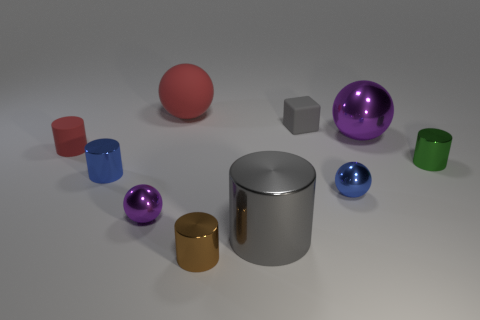How big is the blue metal ball?
Provide a succinct answer. Small. There is a tiny brown metallic thing; what shape is it?
Your answer should be compact. Cylinder. There is a big red thing; is it the same shape as the gray rubber thing behind the green shiny thing?
Provide a succinct answer. No. There is a small thing behind the red rubber cylinder; does it have the same shape as the small brown metallic object?
Give a very brief answer. No. What number of tiny objects are on the left side of the gray shiny thing and behind the gray cylinder?
Provide a succinct answer. 3. What number of other things are the same size as the blue sphere?
Keep it short and to the point. 6. Is the number of big gray metal objects to the left of the blue metal sphere the same as the number of tiny purple blocks?
Provide a short and direct response. No. Does the big shiny object that is to the left of the gray rubber object have the same color as the large sphere that is behind the large purple object?
Ensure brevity in your answer.  No. What is the ball that is both behind the blue sphere and left of the big metallic cylinder made of?
Your answer should be very brief. Rubber. The big shiny cylinder is what color?
Keep it short and to the point. Gray. 